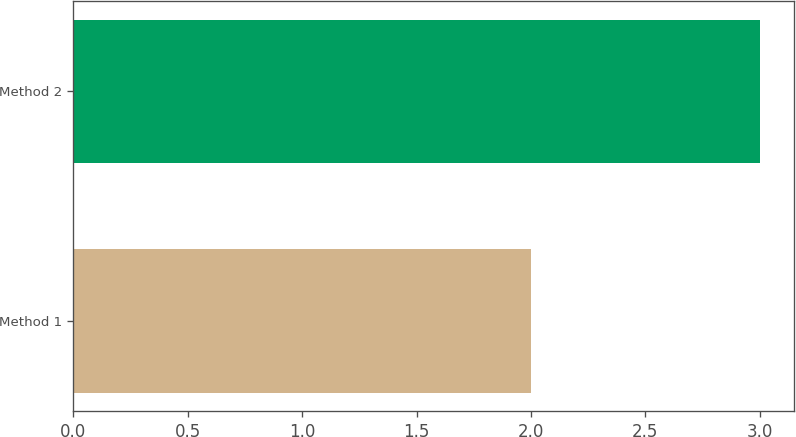<chart> <loc_0><loc_0><loc_500><loc_500><bar_chart><fcel>Method 1<fcel>Method 2<nl><fcel>2<fcel>3<nl></chart> 